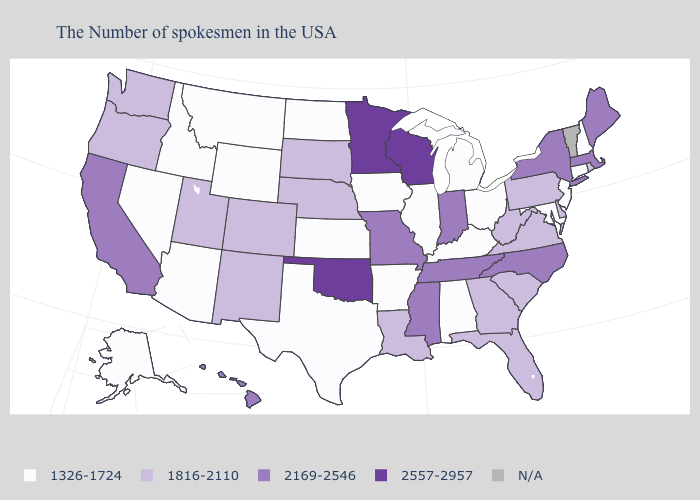What is the highest value in the USA?
Be succinct. 2557-2957. Name the states that have a value in the range 1816-2110?
Quick response, please. Rhode Island, Delaware, Pennsylvania, Virginia, South Carolina, West Virginia, Florida, Georgia, Louisiana, Nebraska, South Dakota, Colorado, New Mexico, Utah, Washington, Oregon. What is the highest value in states that border Maine?
Keep it brief. 1326-1724. Name the states that have a value in the range 1816-2110?
Short answer required. Rhode Island, Delaware, Pennsylvania, Virginia, South Carolina, West Virginia, Florida, Georgia, Louisiana, Nebraska, South Dakota, Colorado, New Mexico, Utah, Washington, Oregon. Does the first symbol in the legend represent the smallest category?
Short answer required. Yes. Does Connecticut have the lowest value in the Northeast?
Quick response, please. Yes. Does North Dakota have the highest value in the USA?
Concise answer only. No. Does the map have missing data?
Write a very short answer. Yes. Among the states that border Mississippi , which have the lowest value?
Short answer required. Alabama, Arkansas. Does Hawaii have the lowest value in the USA?
Answer briefly. No. What is the lowest value in states that border Colorado?
Short answer required. 1326-1724. Name the states that have a value in the range N/A?
Quick response, please. Vermont. Which states have the lowest value in the USA?
Write a very short answer. New Hampshire, Connecticut, New Jersey, Maryland, Ohio, Michigan, Kentucky, Alabama, Illinois, Arkansas, Iowa, Kansas, Texas, North Dakota, Wyoming, Montana, Arizona, Idaho, Nevada, Alaska. 